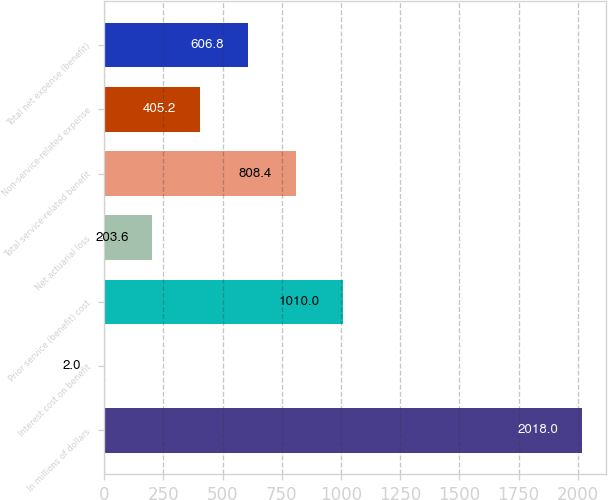<chart> <loc_0><loc_0><loc_500><loc_500><bar_chart><fcel>In millions of dollars<fcel>Interest cost on benefit<fcel>Prior service (benefit) cost<fcel>Net actuarial loss<fcel>Total service-related benefit<fcel>Non-service-related expense<fcel>Total net expense (benefit)<nl><fcel>2018<fcel>2<fcel>1010<fcel>203.6<fcel>808.4<fcel>405.2<fcel>606.8<nl></chart> 